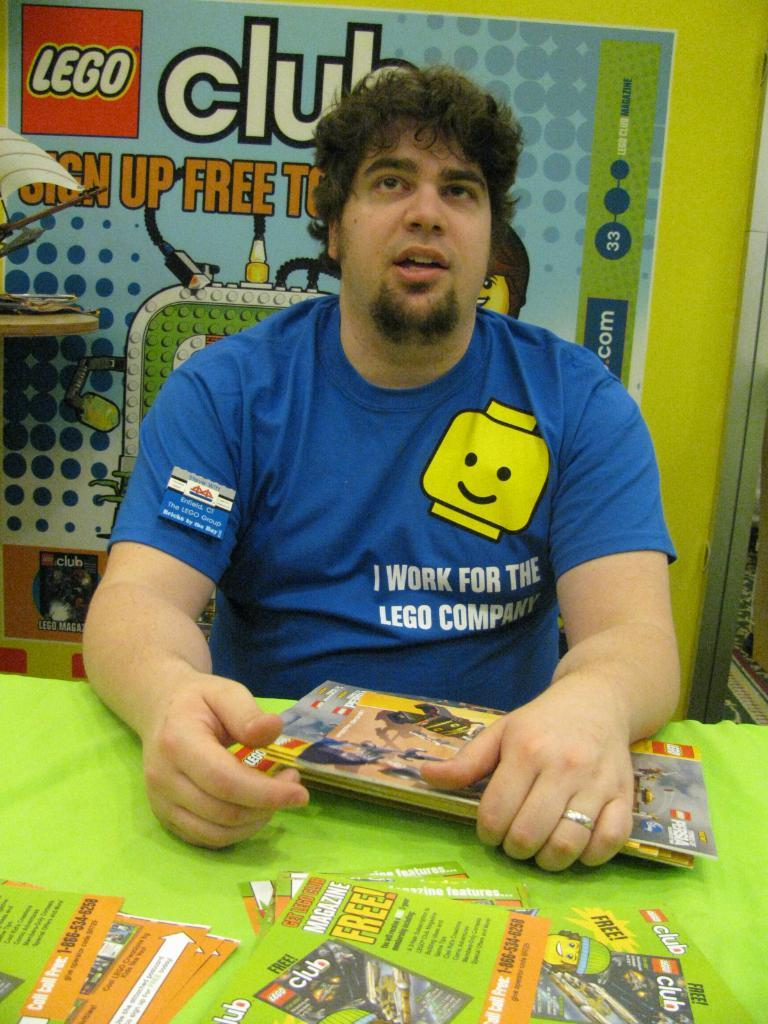What is the man in the image doing? The man is sitting in the image. What is the man holding in the image? The man is holding books. What can be seen on the table in front of the man? There are books and posters on the table in front of the man. What is visible on the table behind the man? There are objects on the table behind the man. What is the background behind the man? There is a poster on a green surface behind the man. What type of pot is visible on the table behind the man? There is no pot visible on the table behind the man in the image. Can you see any ghosts in the image? A: There are no ghosts present in the image. 